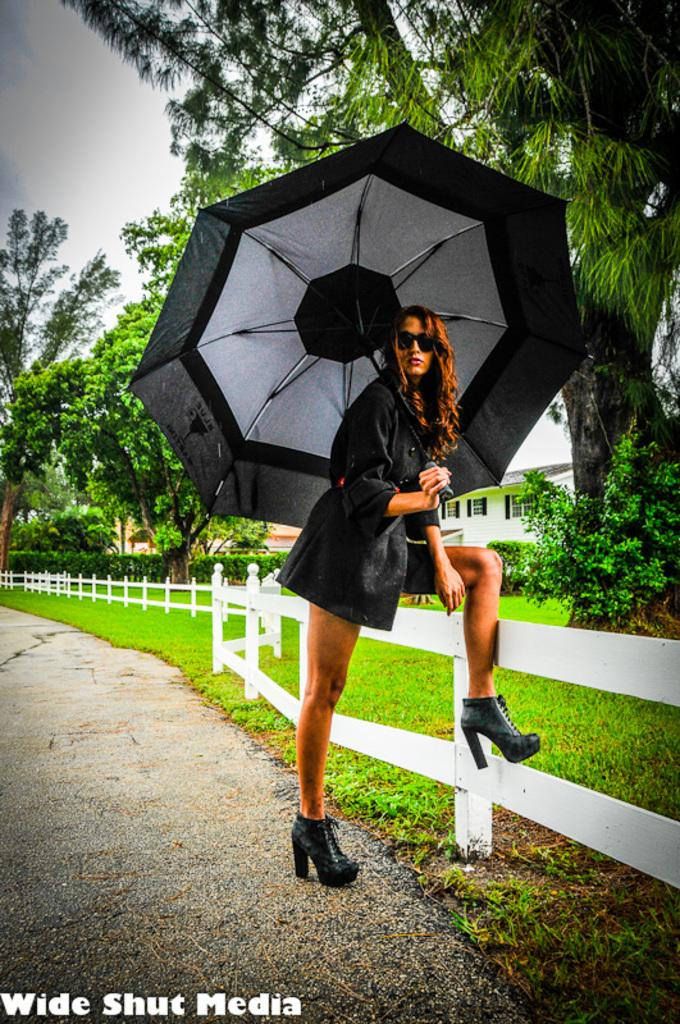What is the main subject of the image? The main subject of the image is a woman. What is the woman doing in the image? The woman is standing on the ground and holding an umbrella. What type of vegetation can be seen in the image? There is grass, plants, and trees visible in the image. What type of structure is present in the image? There is a building in the image. What is the condition of the sky in the image? The sky is visible in the image and appears cloudy. What type of pickle is the woman using to guide the produce in the image? There is no pickle or produce present in the image, and therefore no such activity can be observed. 